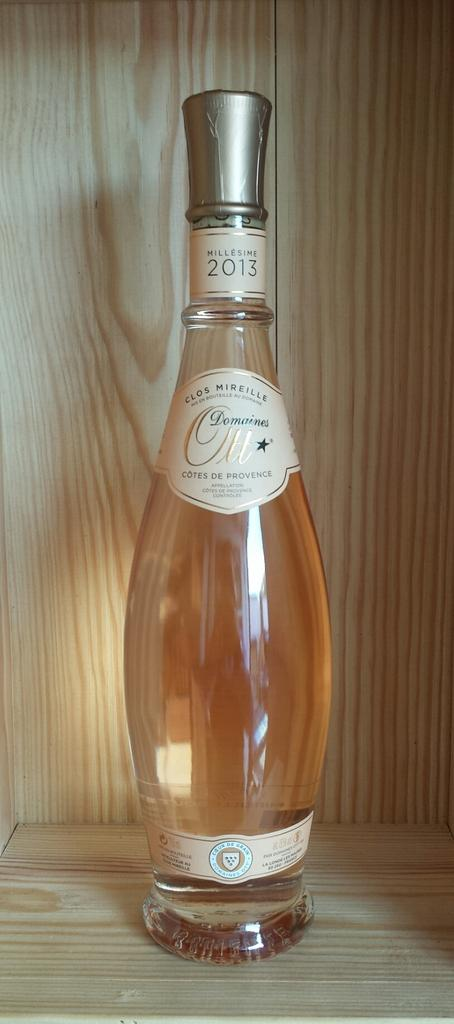What is the main object in the image? There is a wine bottle in the image. Where is the wine bottle placed? The wine bottle is kept on a wooden shelf. What can be seen on the wine bottle? There are labels on the wine bottle. What feature is present on the wine bottle? There is a knob on the wine bottle. Can you tell me how many crackers are on the car in the image? There is no car or crackers present in the image; it features a wine bottle on a wooden shelf. What type of guide is shown assisting with the wine bottle in the image? There is no guide present in the image; it only shows a wine bottle on a wooden shelf with labels and a knob. 